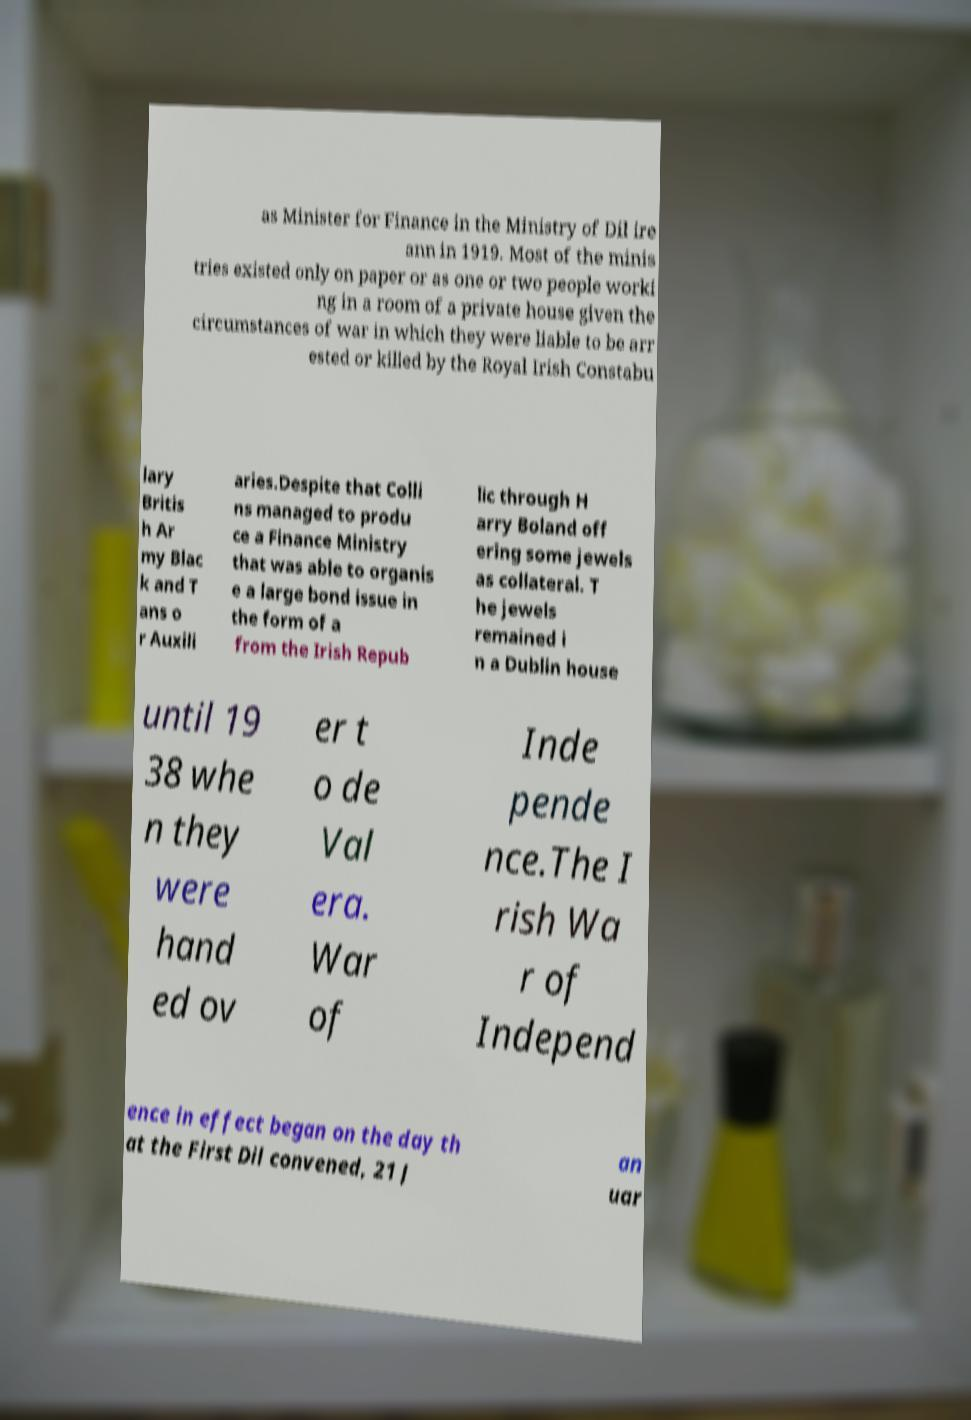Can you read and provide the text displayed in the image?This photo seems to have some interesting text. Can you extract and type it out for me? as Minister for Finance in the Ministry of Dil ire ann in 1919. Most of the minis tries existed only on paper or as one or two people worki ng in a room of a private house given the circumstances of war in which they were liable to be arr ested or killed by the Royal Irish Constabu lary Britis h Ar my Blac k and T ans o r Auxili aries.Despite that Colli ns managed to produ ce a Finance Ministry that was able to organis e a large bond issue in the form of a from the Irish Repub lic through H arry Boland off ering some jewels as collateral. T he jewels remained i n a Dublin house until 19 38 whe n they were hand ed ov er t o de Val era. War of Inde pende nce.The I rish Wa r of Independ ence in effect began on the day th at the First Dil convened, 21 J an uar 